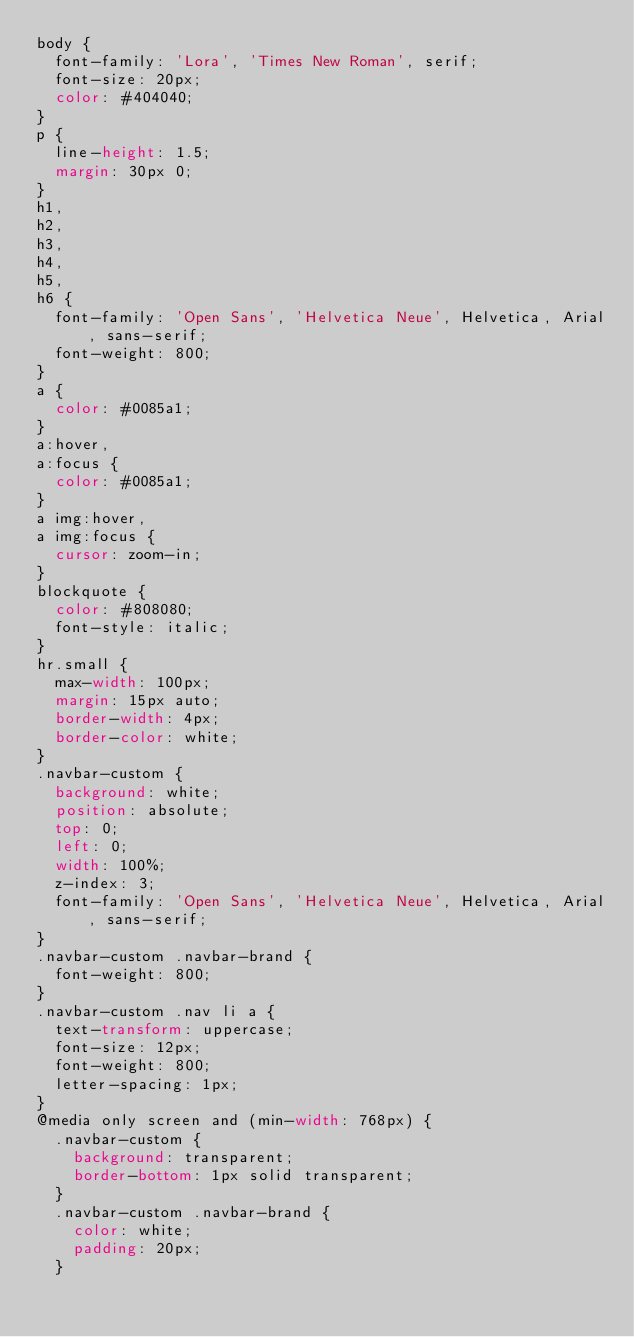<code> <loc_0><loc_0><loc_500><loc_500><_CSS_>body {
  font-family: 'Lora', 'Times New Roman', serif;
  font-size: 20px;
  color: #404040;
}
p {
  line-height: 1.5;
  margin: 30px 0;
}
h1,
h2,
h3,
h4,
h5,
h6 {
  font-family: 'Open Sans', 'Helvetica Neue', Helvetica, Arial, sans-serif;
  font-weight: 800;
}
a {
  color: #0085a1;
}
a:hover,
a:focus {
  color: #0085a1;
}
a img:hover,
a img:focus {
  cursor: zoom-in;
}
blockquote {
  color: #808080;
  font-style: italic;
}
hr.small {
  max-width: 100px;
  margin: 15px auto;
  border-width: 4px;
  border-color: white;
}
.navbar-custom {
  background: white;
  position: absolute;
  top: 0;
  left: 0;
  width: 100%;
  z-index: 3;
  font-family: 'Open Sans', 'Helvetica Neue', Helvetica, Arial, sans-serif;
}
.navbar-custom .navbar-brand {
  font-weight: 800;
}
.navbar-custom .nav li a {
  text-transform: uppercase;
  font-size: 12px;
  font-weight: 800;
  letter-spacing: 1px;
}
@media only screen and (min-width: 768px) {
  .navbar-custom {
    background: transparent;
    border-bottom: 1px solid transparent;
  }
  .navbar-custom .navbar-brand {
    color: white;
    padding: 20px;
  }</code> 